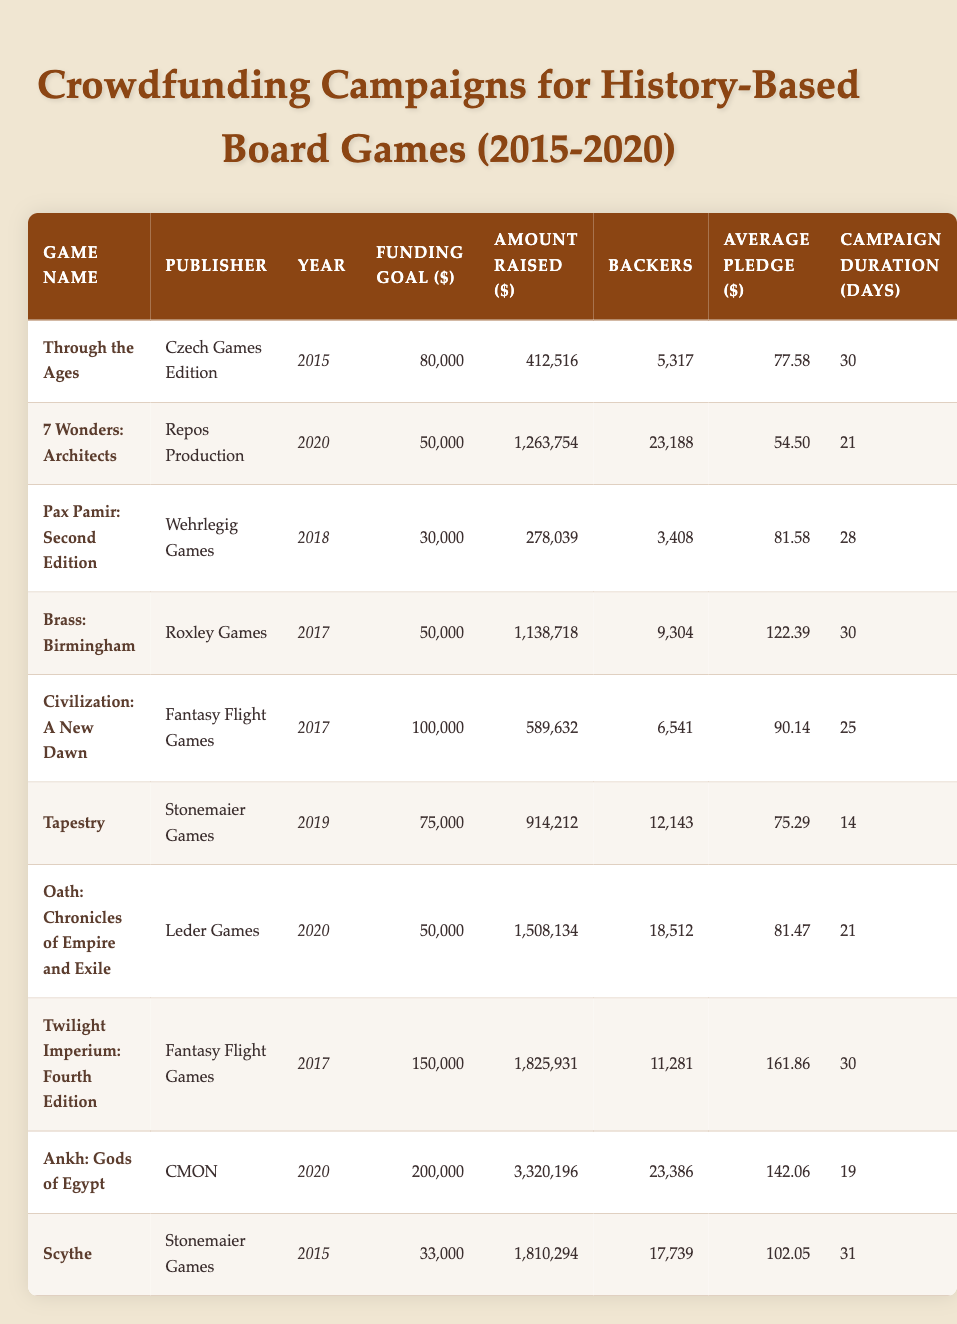What was the funding goal for "Scythe"? The funding goal is listed in the row corresponding to "Scythe." According to the table, the funding goal is $33,000.
Answer: 33,000 How much amount was raised for "Brass: Birmingham"? Looking at the row for "Brass: Birmingham," the amount raised is shown as $1,138,718.
Answer: 1,138,718 How many backers did "Ankh: Gods of Egypt" have? By checking the row for "Ankh: Gods of Egypt," the number of backers is provided as 23,386.
Answer: 23,386 What is the average pledge for the game with the highest amount raised? "Ankh: Gods of Egypt" has the highest amount raised ($3,320,196), and its average pledge is $142.06. Thus, the average pledge for this game is $142.06.
Answer: 142.06 Which game had the longest campaign duration, and how long was it? By examining the campaign duration for each game, "Scythe" and "Through the Ages" both had a campaign duration of 31 days, which is the longest duration in the table.
Answer: Scythe, 31 What is the total funding goal for all campaigns listed? To find the total funding goal, we sum the funding goals for each game: 80,000 + 50,000 + 30,000 + 50,000 + 100,000 + 75,000 + 50,000 + 150,000 + 200,000 + 33,000. This results in a total of $8,395,000.
Answer: 8,395,000 Was the "Oath: Chronicles of Empire and Exile" campaign successful? A campaign is considered successful if the amount raised is greater than the funding goal. "Oath: Chronicles of Empire and Exile" had a funding goal of $50,000 and raised $1,508,134, which is significantly more than the goal. Therefore, the campaign was successful.
Answer: Yes How many backers did the two games with the most funding goals combined have? The two games with the most funding goals are "Ankh: Gods of Egypt" with $200,000 and "Twilight Imperium: Fourth Edition" with $150,000. Their backers are 23,386 and 11,281 respectively. The combined number of backers is 23,386 + 11,281 = 34,667.
Answer: 34,667 Which publisher had the highest average pledge? Analyzing the average pledges by publisher, "Twilight Imperium: Fourth Edition" published by Fantasy Flight Games has an average pledge of $161.86, which is the highest in the table.
Answer: Fantasy Flight Games, 161.86 